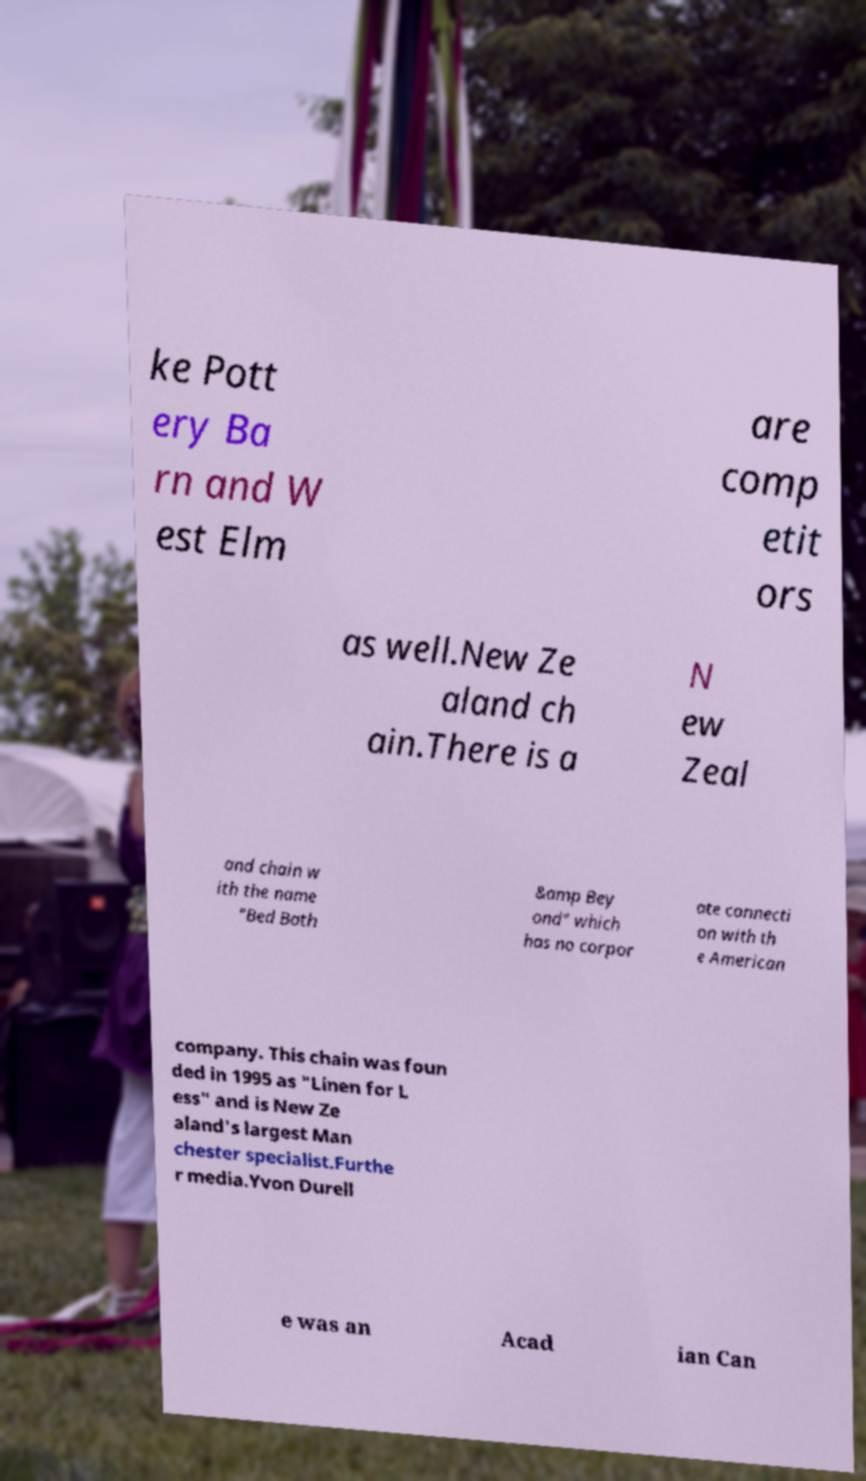For documentation purposes, I need the text within this image transcribed. Could you provide that? ke Pott ery Ba rn and W est Elm are comp etit ors as well.New Ze aland ch ain.There is a N ew Zeal and chain w ith the name "Bed Bath &amp Bey ond" which has no corpor ate connecti on with th e American company. This chain was foun ded in 1995 as "Linen for L ess" and is New Ze aland's largest Man chester specialist.Furthe r media.Yvon Durell e was an Acad ian Can 